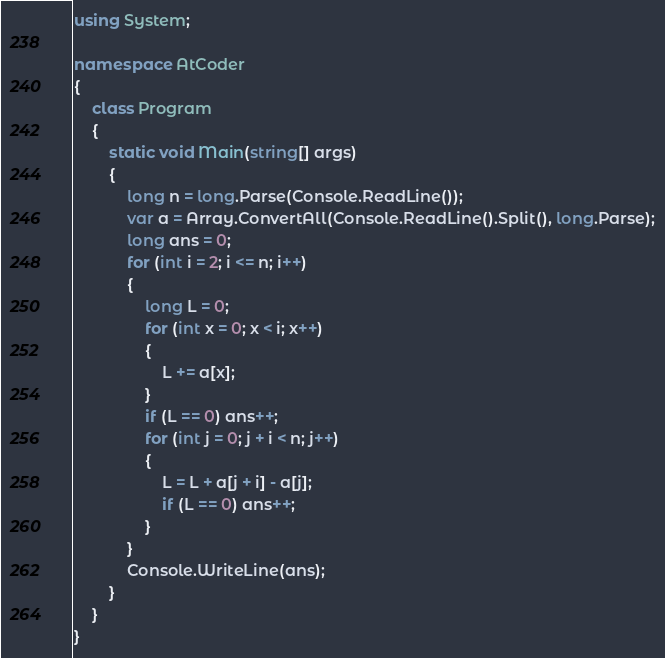<code> <loc_0><loc_0><loc_500><loc_500><_C#_>using System;

namespace AtCoder
{
    class Program
    {
        static void Main(string[] args)
        {
            long n = long.Parse(Console.ReadLine());
            var a = Array.ConvertAll(Console.ReadLine().Split(), long.Parse);
            long ans = 0;
            for (int i = 2; i <= n; i++)
            {
                long L = 0;
                for (int x = 0; x < i; x++)
                {
                    L += a[x];
                }
                if (L == 0) ans++;
                for (int j = 0; j + i < n; j++)
                {
                    L = L + a[j + i] - a[j];
                    if (L == 0) ans++;
                }
            }
            Console.WriteLine(ans);
        }
    }
}</code> 